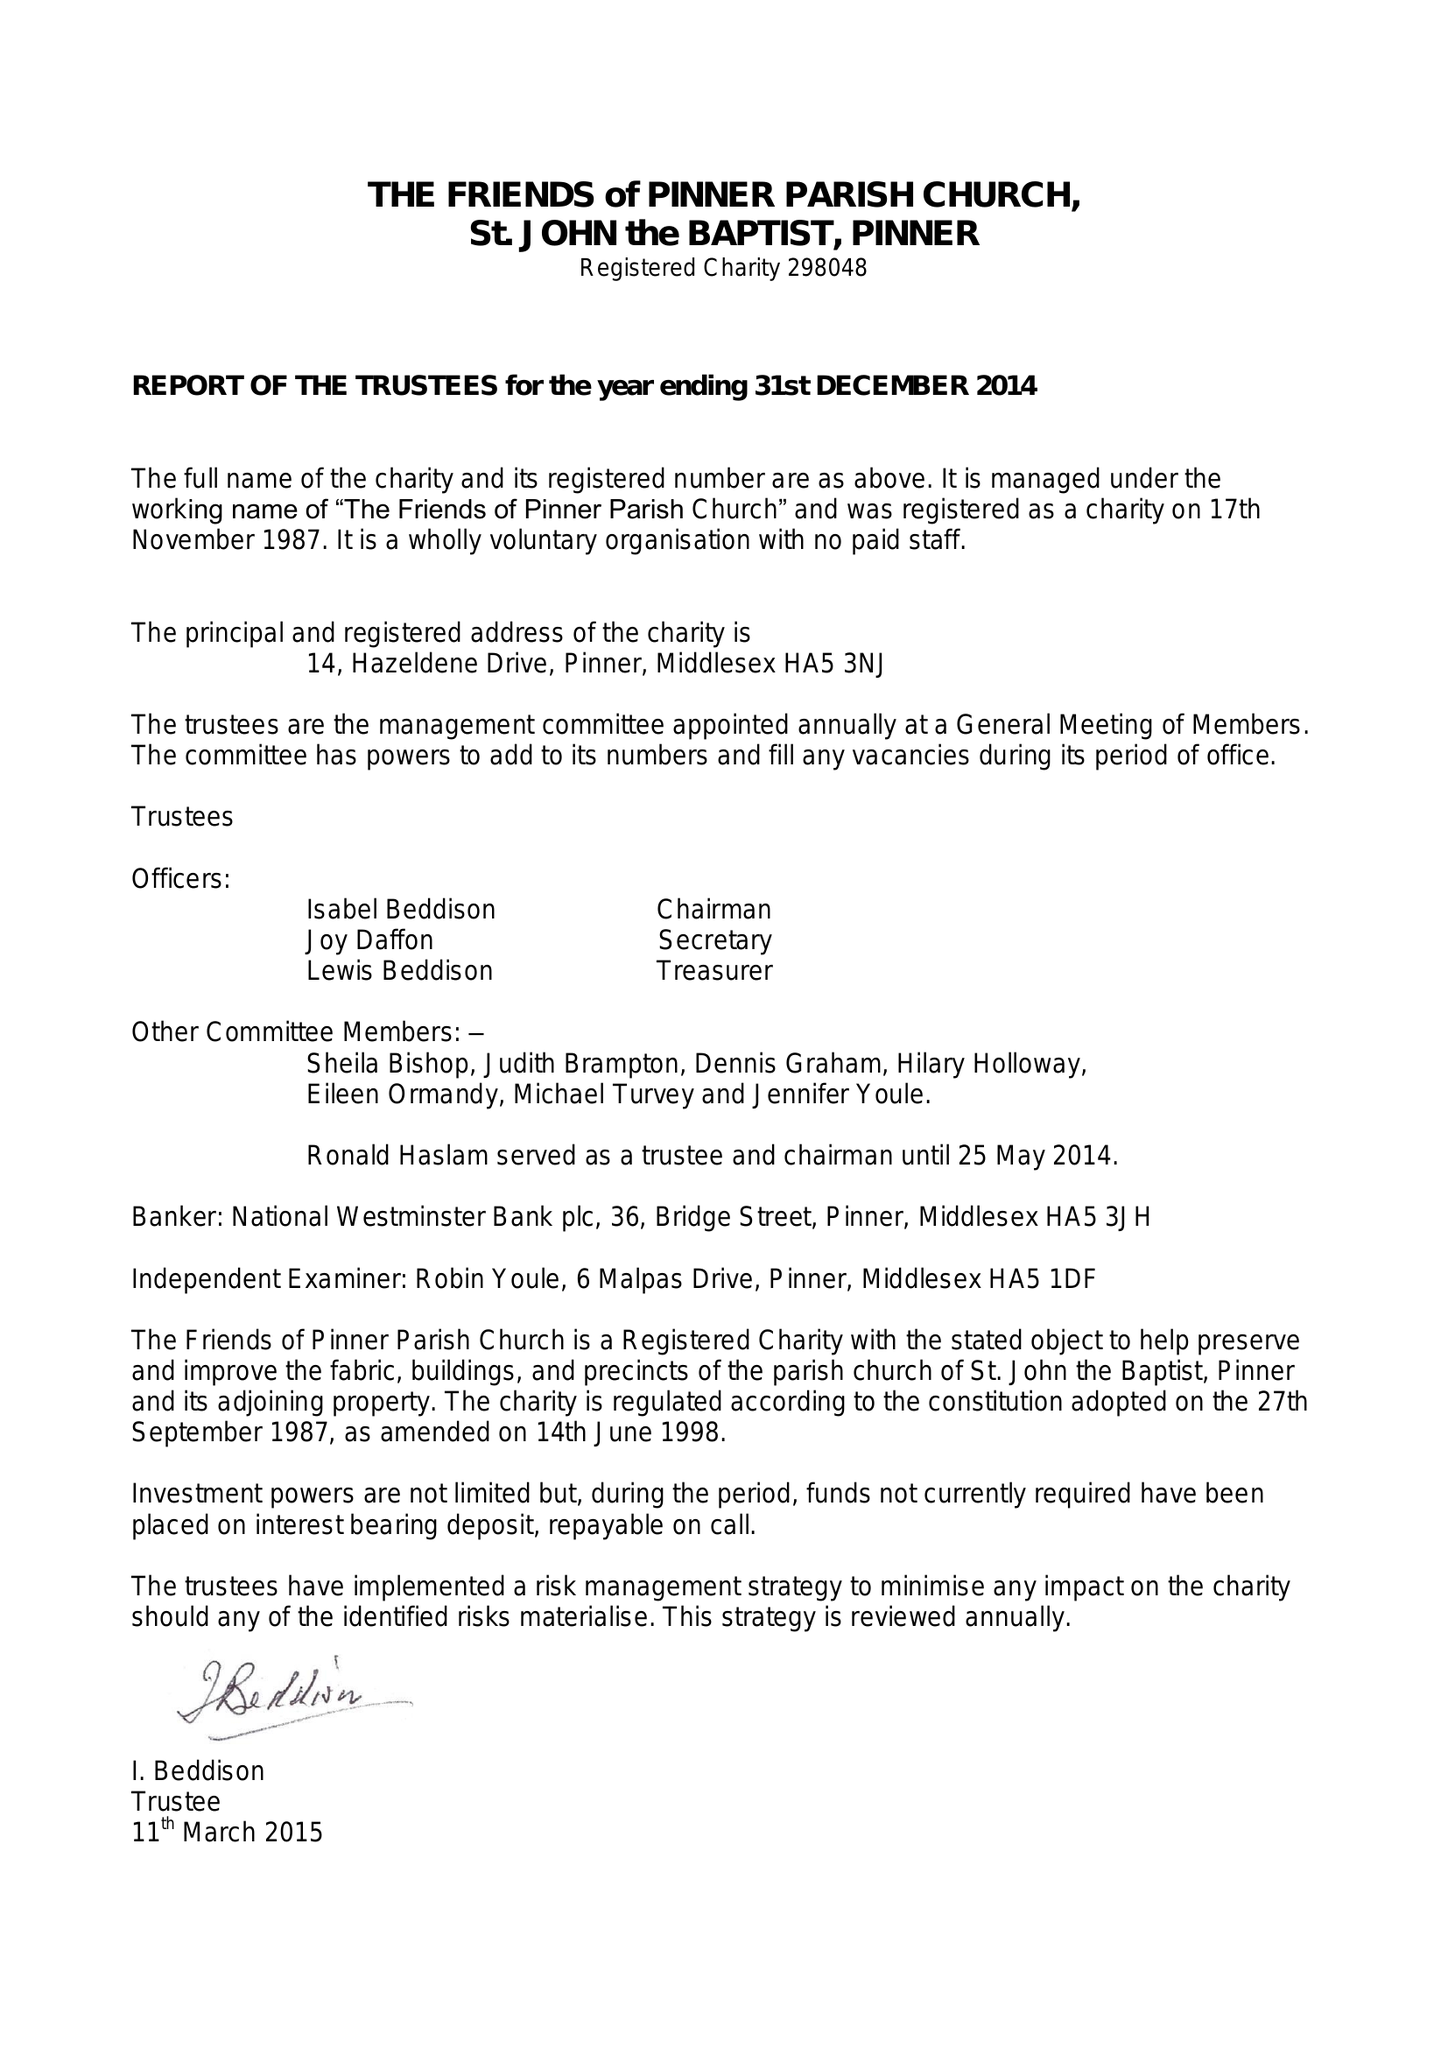What is the value for the address__postcode?
Answer the question using a single word or phrase. HA5 3NJ 